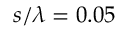Convert formula to latex. <formula><loc_0><loc_0><loc_500><loc_500>s / \lambda = 0 . 0 5</formula> 